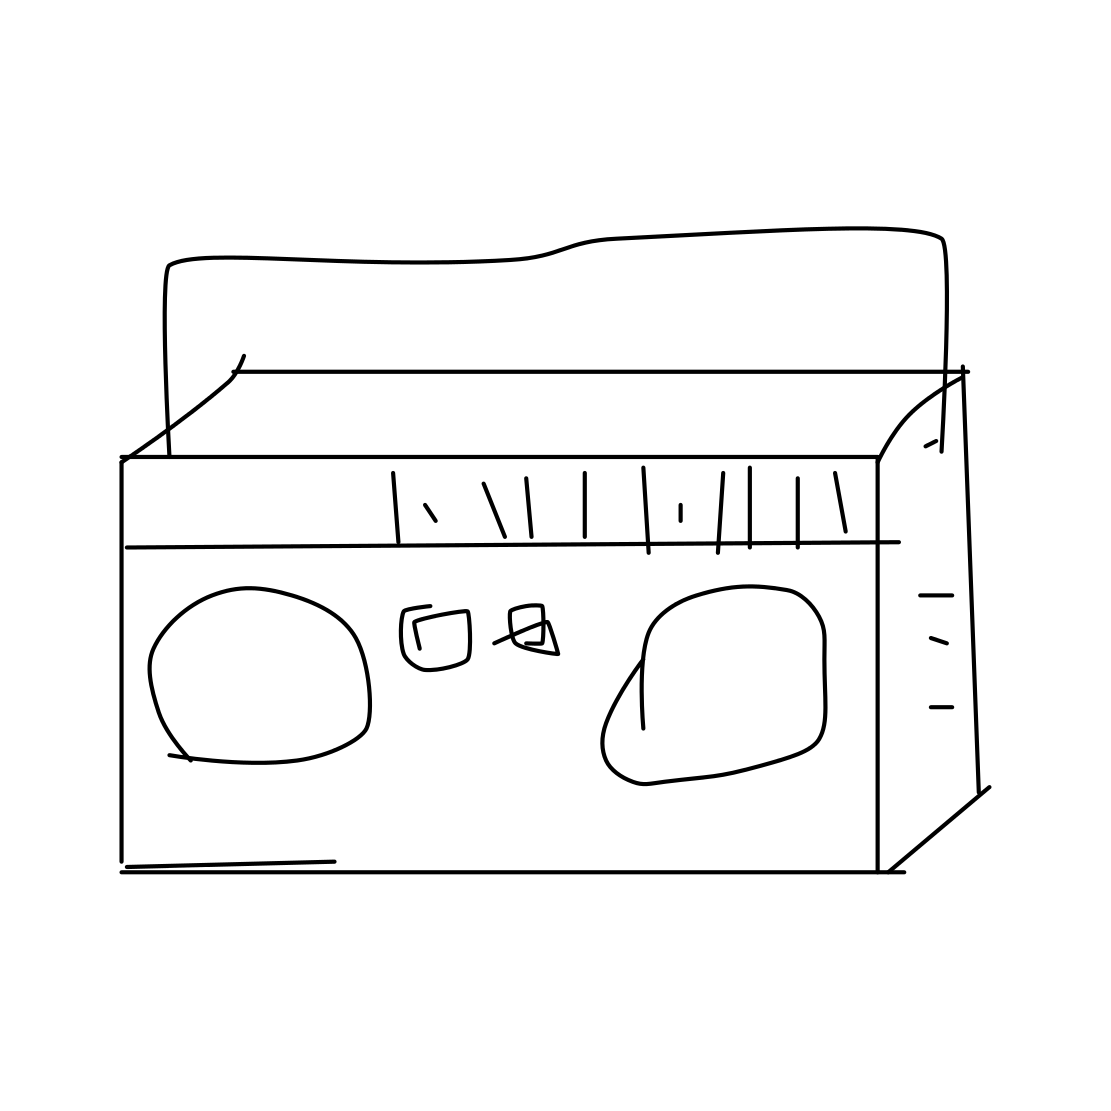Could you tell me more about this particular design? This particular drawing simplifies the design of a cassette tape, featuring its rectangular shape, central window where you can see the spools, and the holes where the spindles of a cassette player would rotate the reels to read the tape. It's a minimalist representation that captures the essence of a traditional cassette tape. 